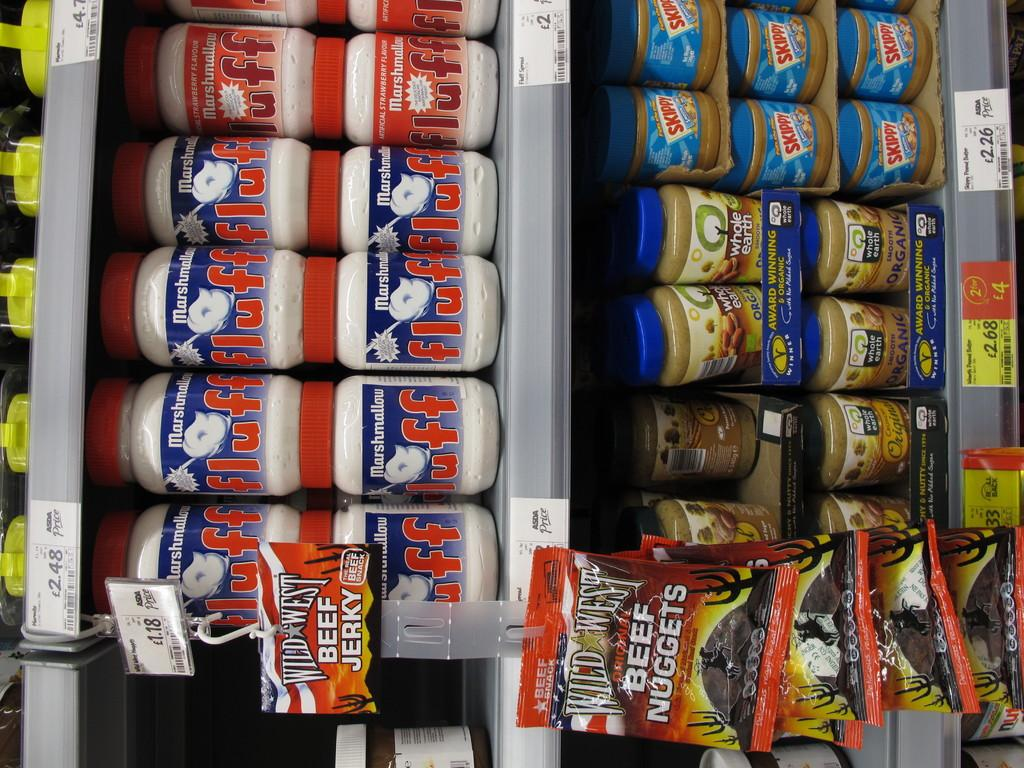<image>
Render a clear and concise summary of the photo. Beef Nuggets are hanging from the clips on the isle. 